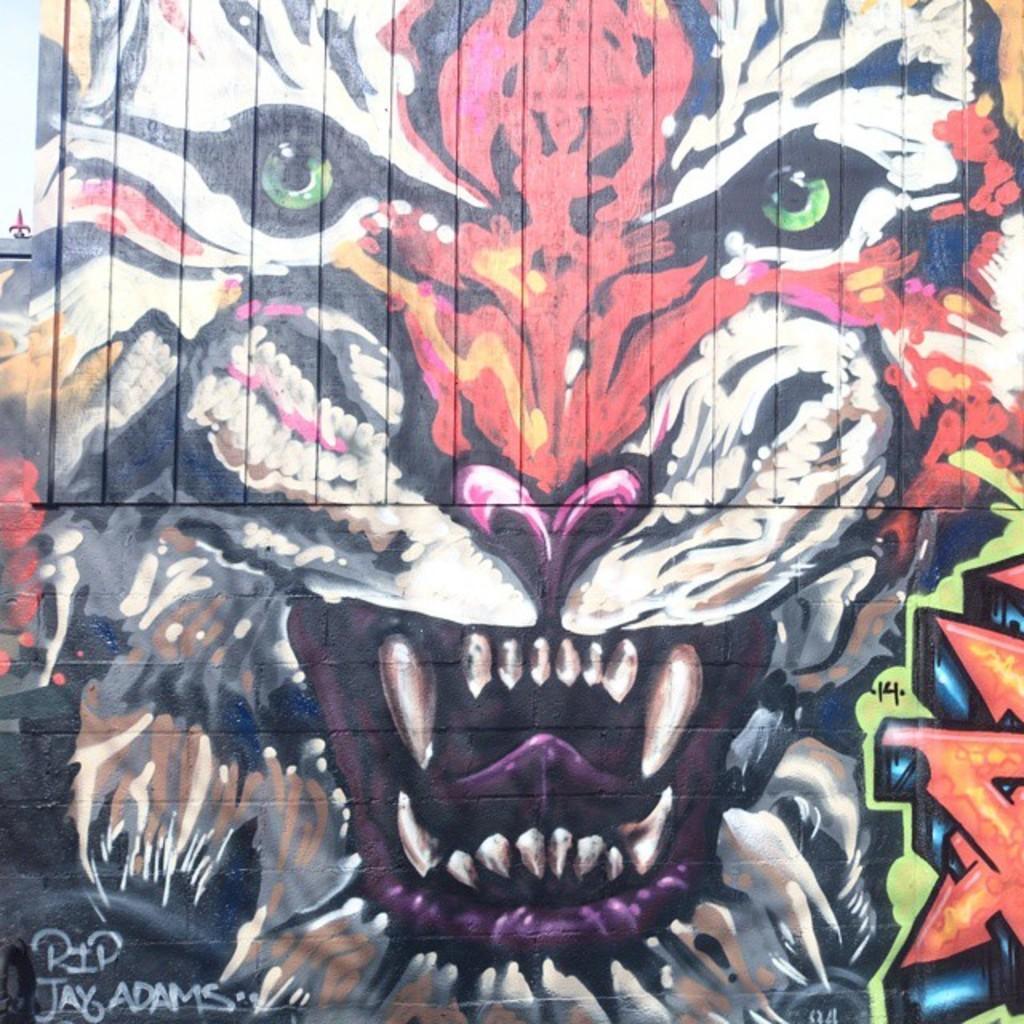In one or two sentences, can you explain what this image depicts? Here in this picture we can see a graffiti painting of a tiger represent on the wall over there. 